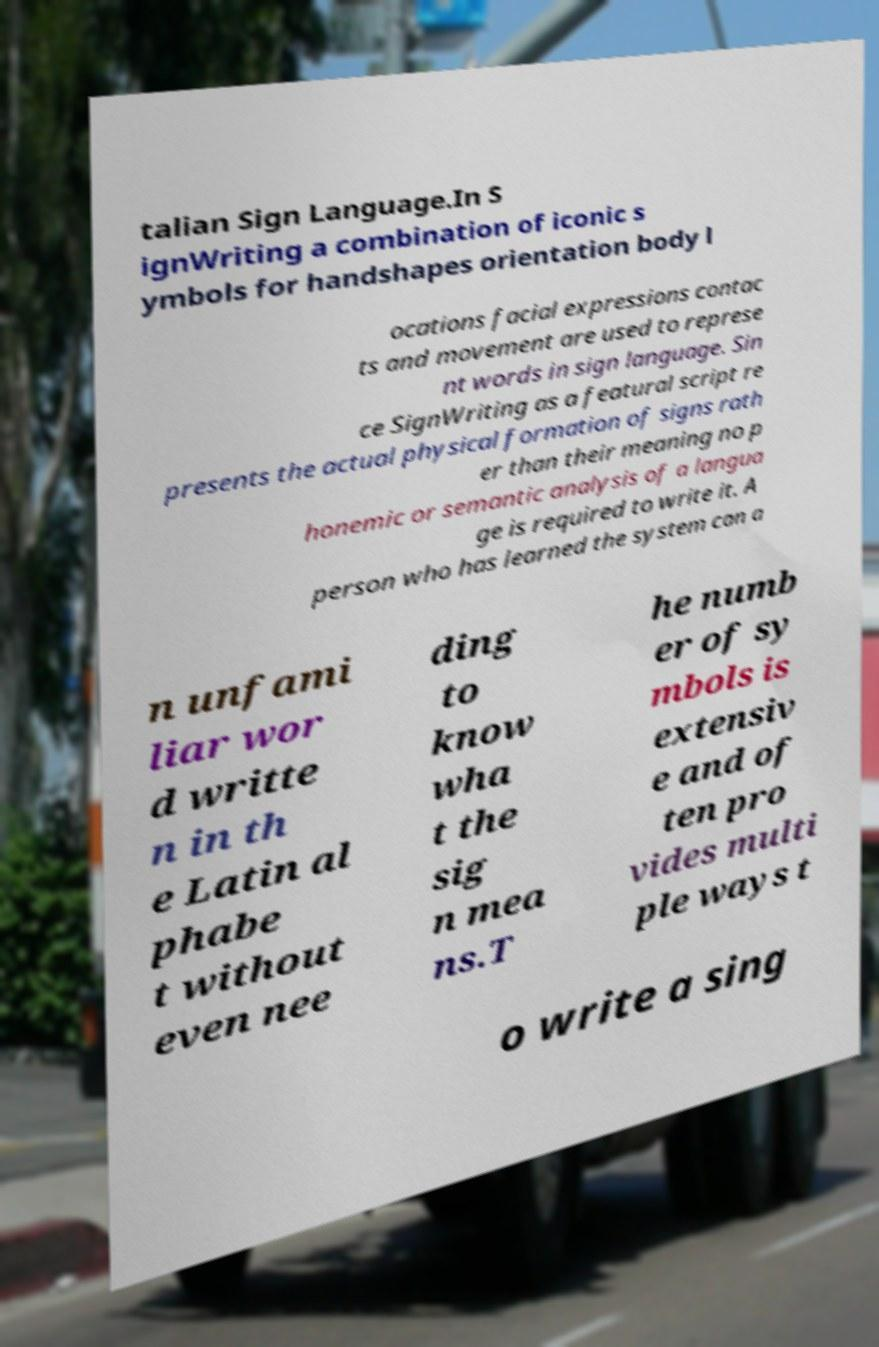Please read and relay the text visible in this image. What does it say? talian Sign Language.In S ignWriting a combination of iconic s ymbols for handshapes orientation body l ocations facial expressions contac ts and movement are used to represe nt words in sign language. Sin ce SignWriting as a featural script re presents the actual physical formation of signs rath er than their meaning no p honemic or semantic analysis of a langua ge is required to write it. A person who has learned the system can a n unfami liar wor d writte n in th e Latin al phabe t without even nee ding to know wha t the sig n mea ns.T he numb er of sy mbols is extensiv e and of ten pro vides multi ple ways t o write a sing 